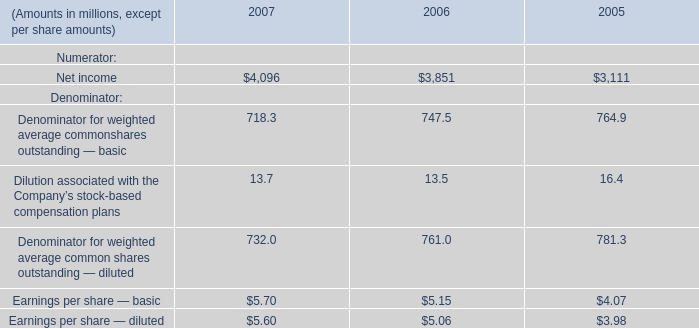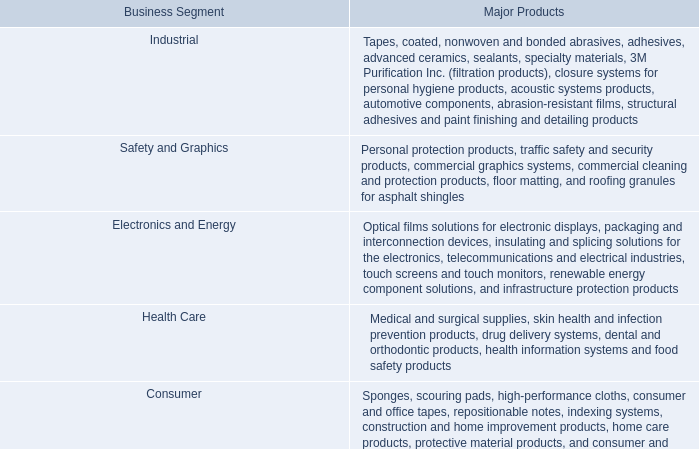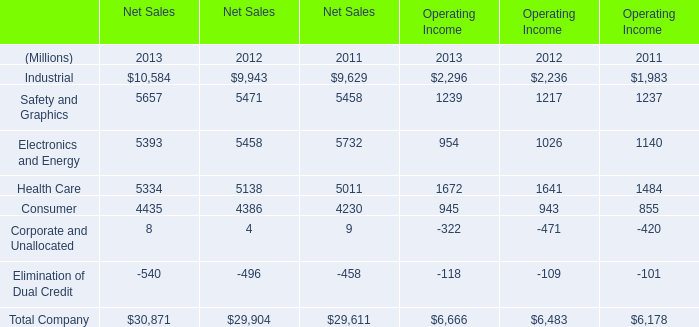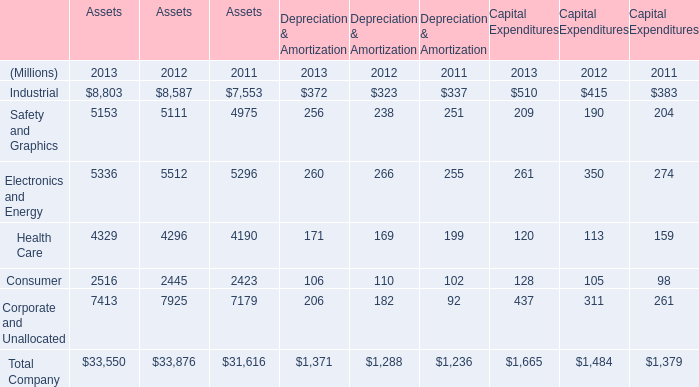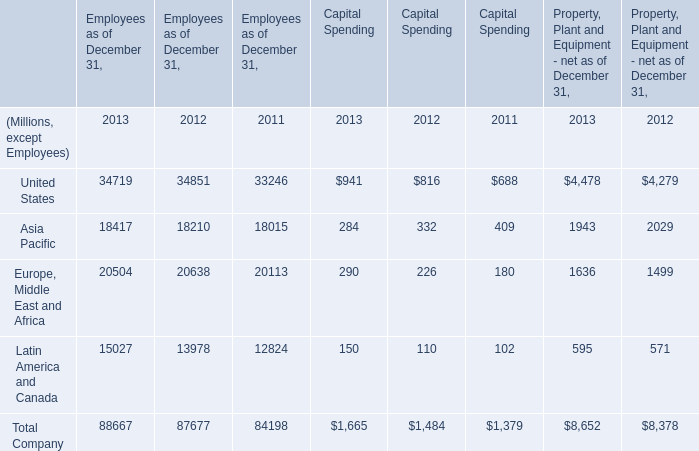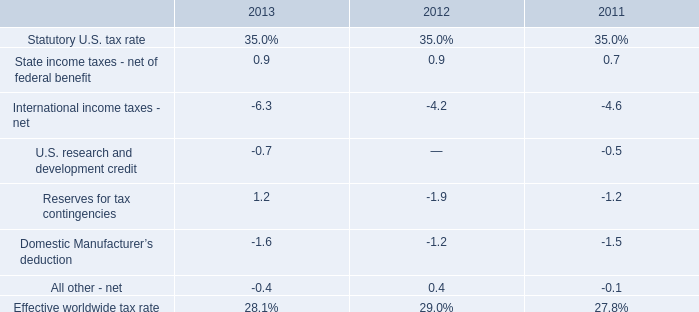what was the ratio of the company contribution in 2011 to the amount in 2013 to the us pension contributions 
Computations: (517 / 476)
Answer: 1.08613. 